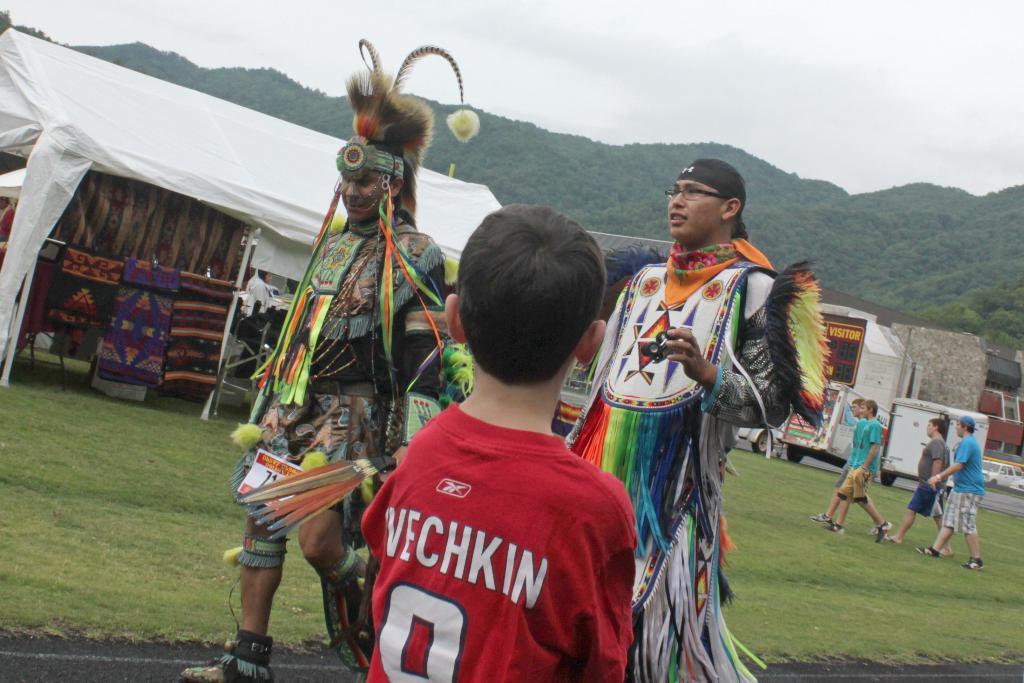In one or two sentences, can you explain what this image depicts? In this image I can see a boy is looking at his side, he wore red color t-shirt. In the middle a man is walking, he wore different types of things. On the left side there is a shed covered with a white color cover. On the right side there are vehicles, at the back side there are hills with green trees, at the top it is the sky. 